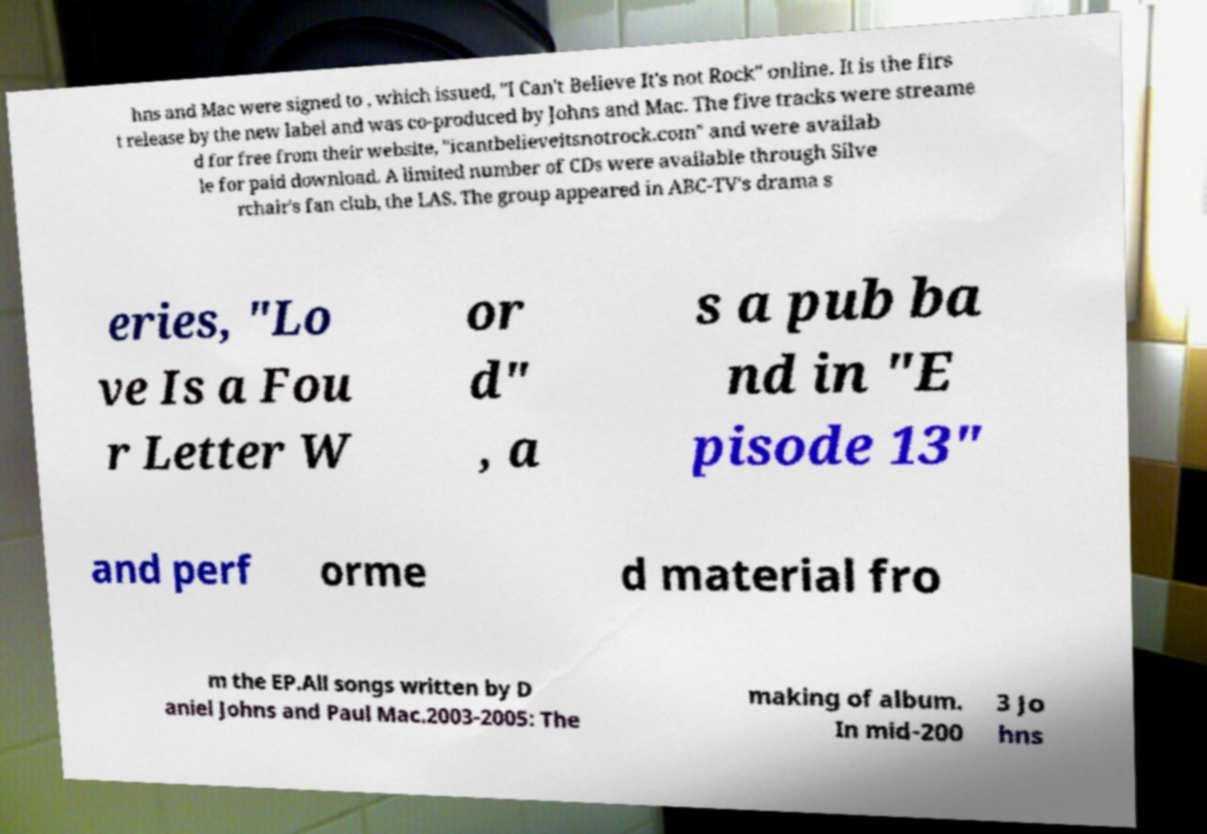Could you assist in decoding the text presented in this image and type it out clearly? hns and Mac were signed to , which issued, "I Can't Believe It's not Rock" online. It is the firs t release by the new label and was co-produced by Johns and Mac. The five tracks were streame d for free from their website, "icantbelieveitsnotrock.com" and were availab le for paid download. A limited number of CDs were available through Silve rchair's fan club, the LAS. The group appeared in ABC-TV's drama s eries, "Lo ve Is a Fou r Letter W or d" , a s a pub ba nd in "E pisode 13" and perf orme d material fro m the EP.All songs written by D aniel Johns and Paul Mac.2003-2005: The making of album. In mid-200 3 Jo hns 